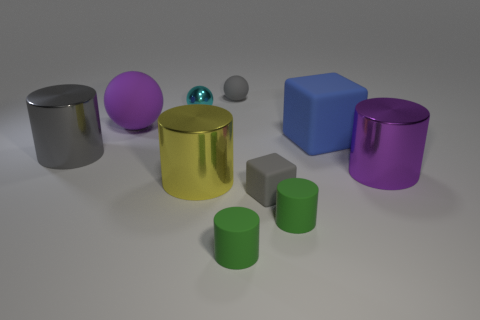There is a gray object that is the same shape as the cyan metal thing; what is its size?
Your response must be concise. Small. Are there fewer tiny rubber cubes to the right of the big rubber block than large purple cylinders on the right side of the yellow shiny object?
Keep it short and to the point. Yes. The rubber object that is both on the right side of the tiny gray rubber ball and behind the gray cylinder has what shape?
Make the answer very short. Cube. The cube that is the same material as the big blue object is what size?
Give a very brief answer. Small. Do the small matte ball and the small shiny thing behind the blue rubber cube have the same color?
Ensure brevity in your answer.  No. What is the tiny thing that is right of the yellow object and behind the large purple matte sphere made of?
Provide a short and direct response. Rubber. What is the size of the matte ball that is the same color as the tiny block?
Offer a terse response. Small. Is the shape of the rubber thing that is left of the gray sphere the same as the small thing left of the gray sphere?
Your response must be concise. Yes. Are any small yellow rubber things visible?
Offer a terse response. No. There is another tiny thing that is the same shape as the cyan object; what is its color?
Your response must be concise. Gray. 